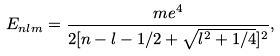<formula> <loc_0><loc_0><loc_500><loc_500>E _ { n l m } = \frac { m e ^ { 4 } } { 2 [ n - l - 1 / 2 + \sqrt { l ^ { 2 } + 1 / 4 } ] ^ { 2 } } ,</formula> 